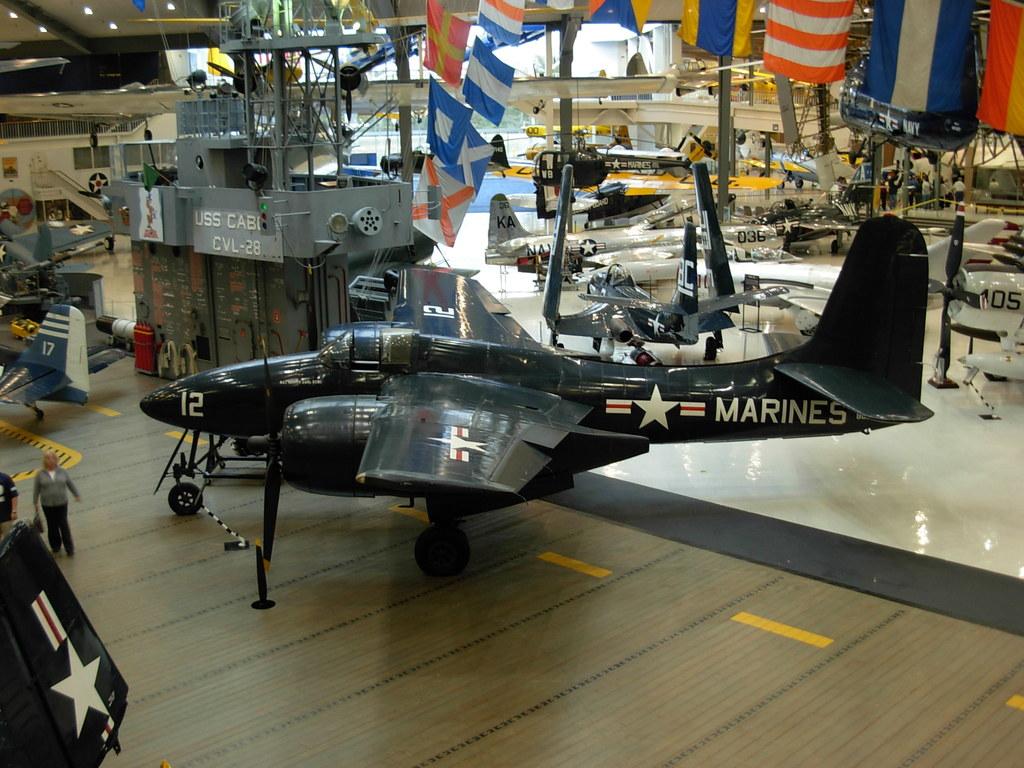What number is the plane?
Make the answer very short. 12. 